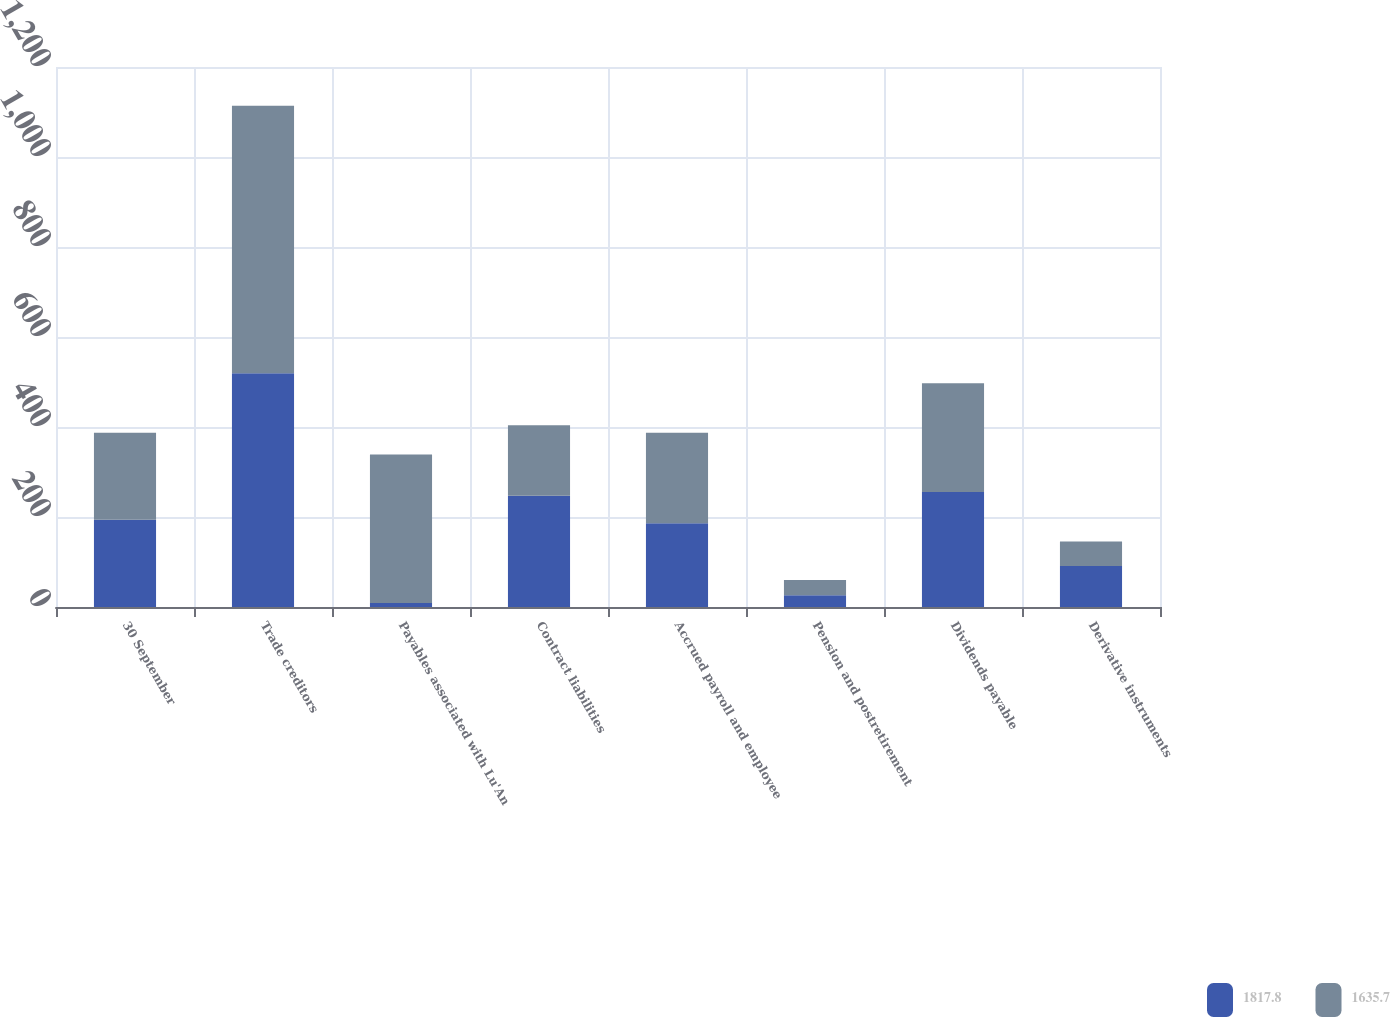Convert chart. <chart><loc_0><loc_0><loc_500><loc_500><stacked_bar_chart><ecel><fcel>30 September<fcel>Trade creditors<fcel>Payables associated with Lu'An<fcel>Contract liabilities<fcel>Accrued payroll and employee<fcel>Pension and postretirement<fcel>Dividends payable<fcel>Derivative instruments<nl><fcel>1817.8<fcel>193.75<fcel>519.3<fcel>8.9<fcel>247.4<fcel>186.1<fcel>26<fcel>255.7<fcel>91.2<nl><fcel>1635.7<fcel>193.75<fcel>594.6<fcel>330<fcel>156.6<fcel>201.4<fcel>34.1<fcel>241.5<fcel>54.2<nl></chart> 